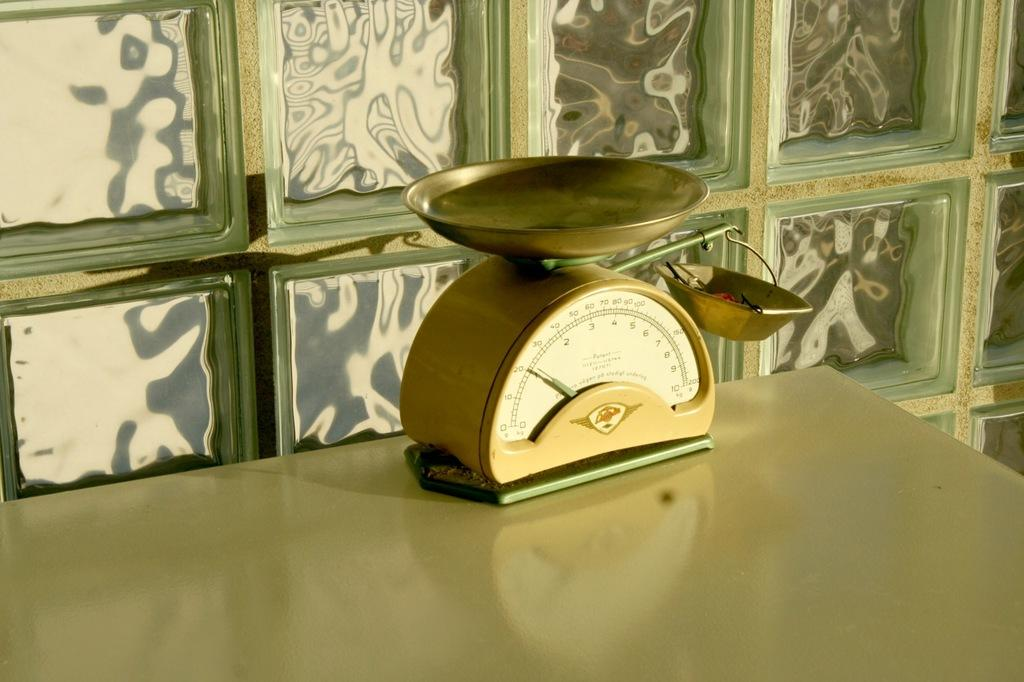What is the main object in the image? There is a weighing machine in the image. Where is the weighing machine located? The weighing machine is placed on a table. What can be seen in the background of the image? There is a wall in the background of the image. What type of authority is depicted in the image? There is no authority figure present in the image; it features a weighing machine on a table with a wall in the background. How does the weighing machine contribute to harmony in the image? The weighing machine does not contribute to harmony in the image, as it is an inanimate object. 